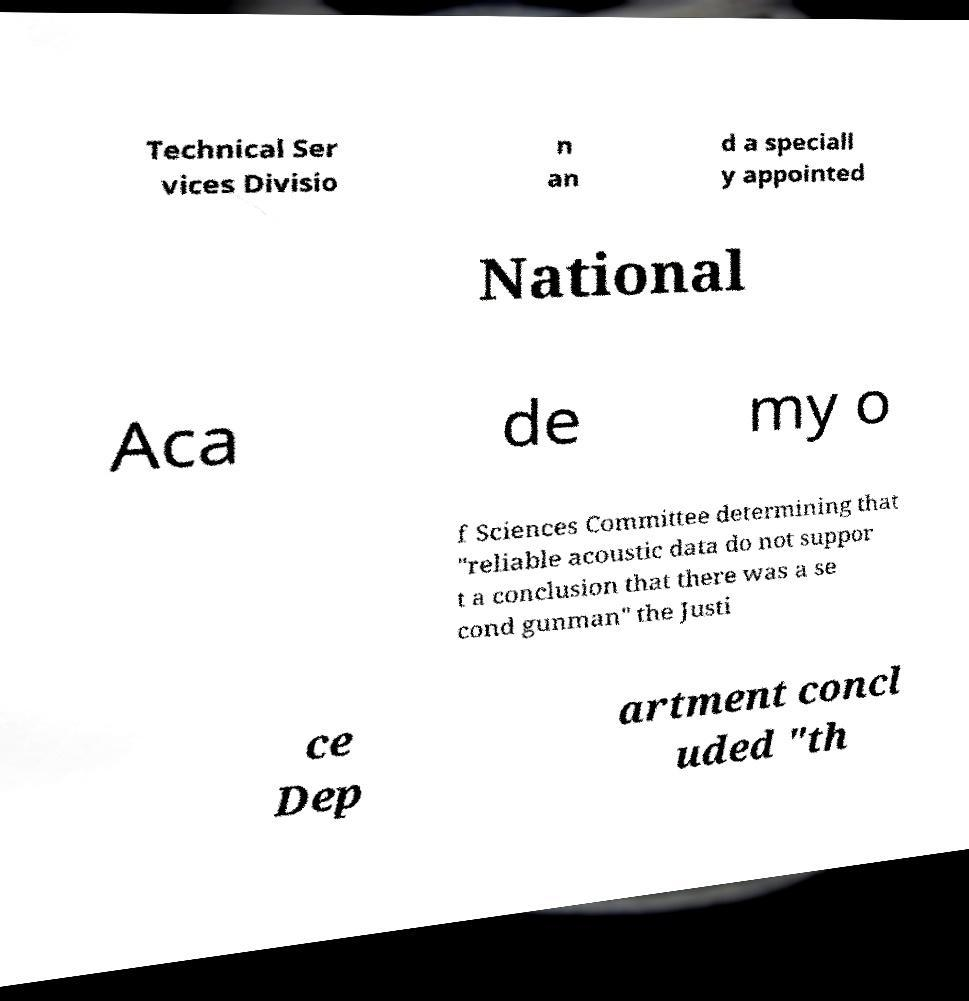For documentation purposes, I need the text within this image transcribed. Could you provide that? Technical Ser vices Divisio n an d a speciall y appointed National Aca de my o f Sciences Committee determining that "reliable acoustic data do not suppor t a conclusion that there was a se cond gunman" the Justi ce Dep artment concl uded "th 